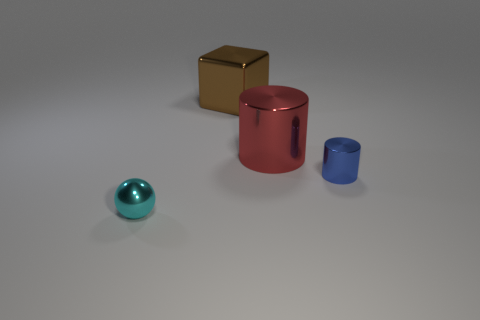There is another object that is the same shape as the big red metal thing; what is it made of? metal 